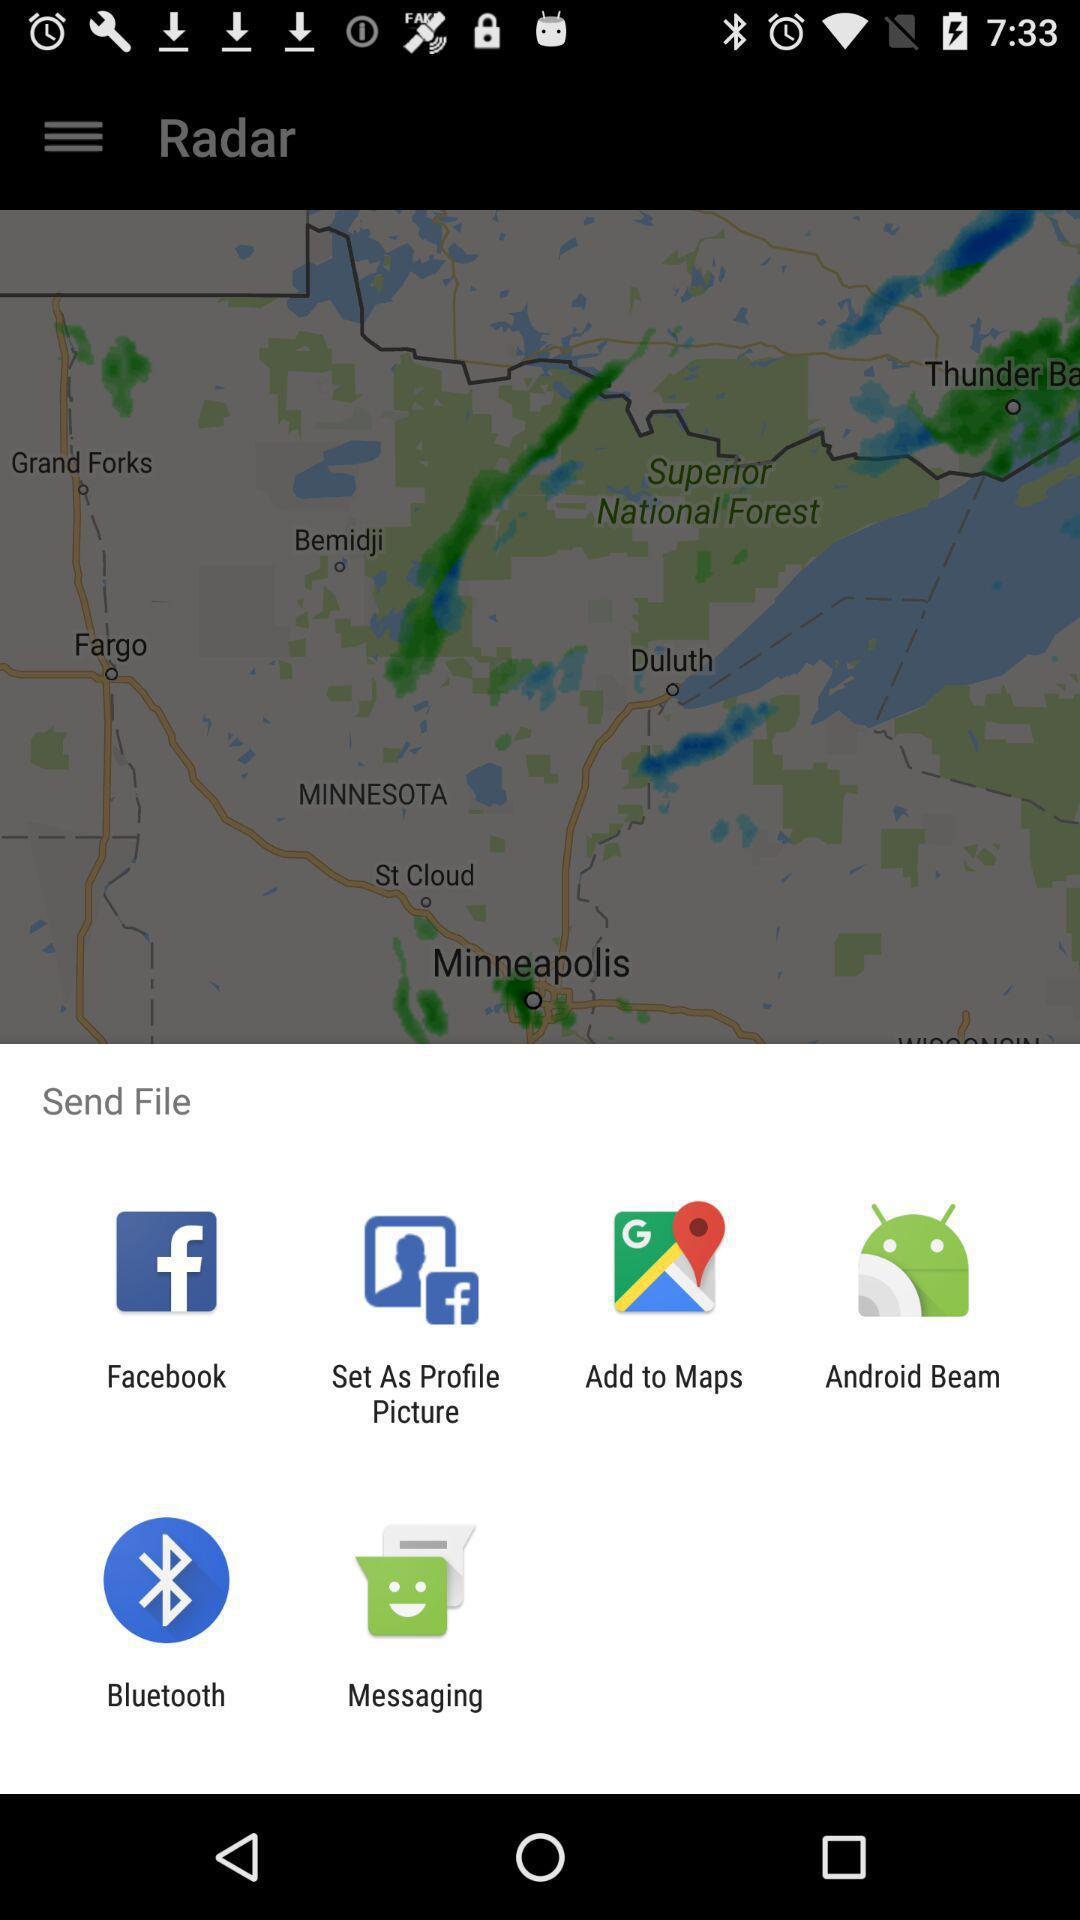What are the available sending options? The available sending options are "Facebook", "Set As Profile Picture", "Add to Maps", "Android Beam", "Bluetooth" and "Messaging". 